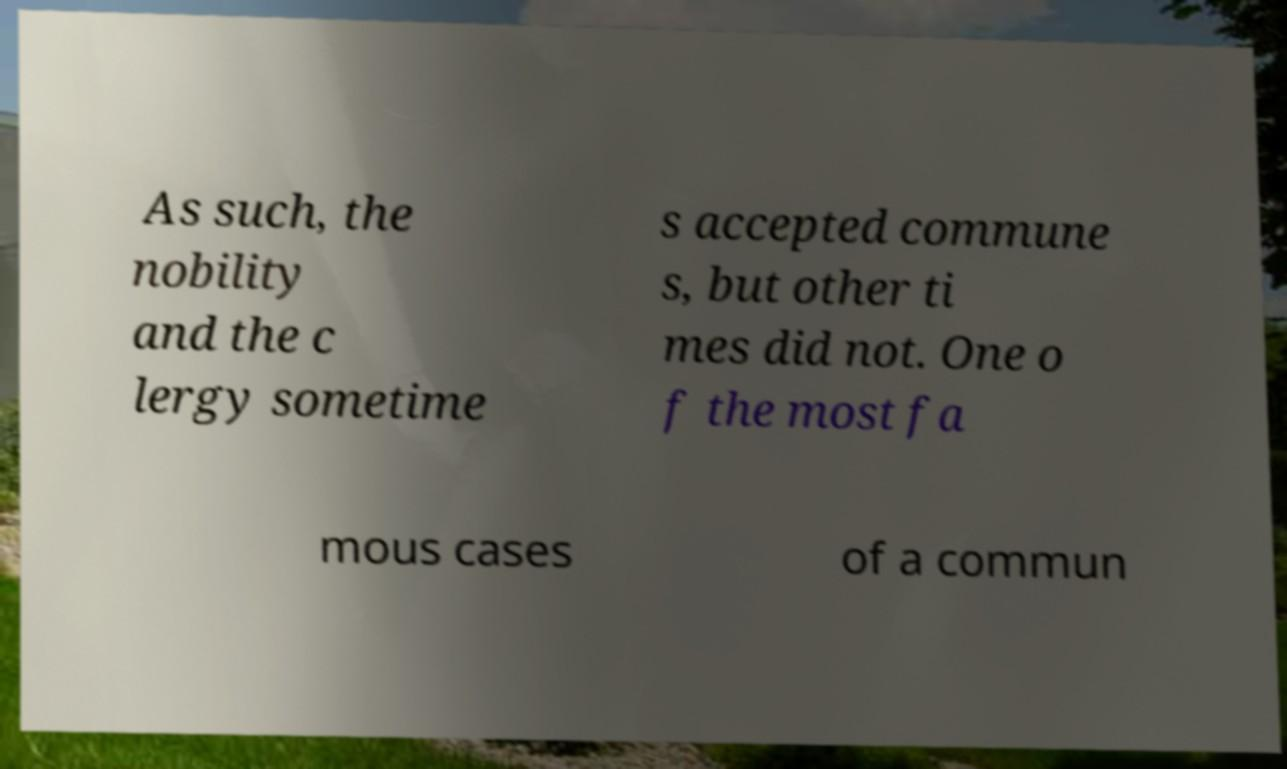Could you assist in decoding the text presented in this image and type it out clearly? As such, the nobility and the c lergy sometime s accepted commune s, but other ti mes did not. One o f the most fa mous cases of a commun 